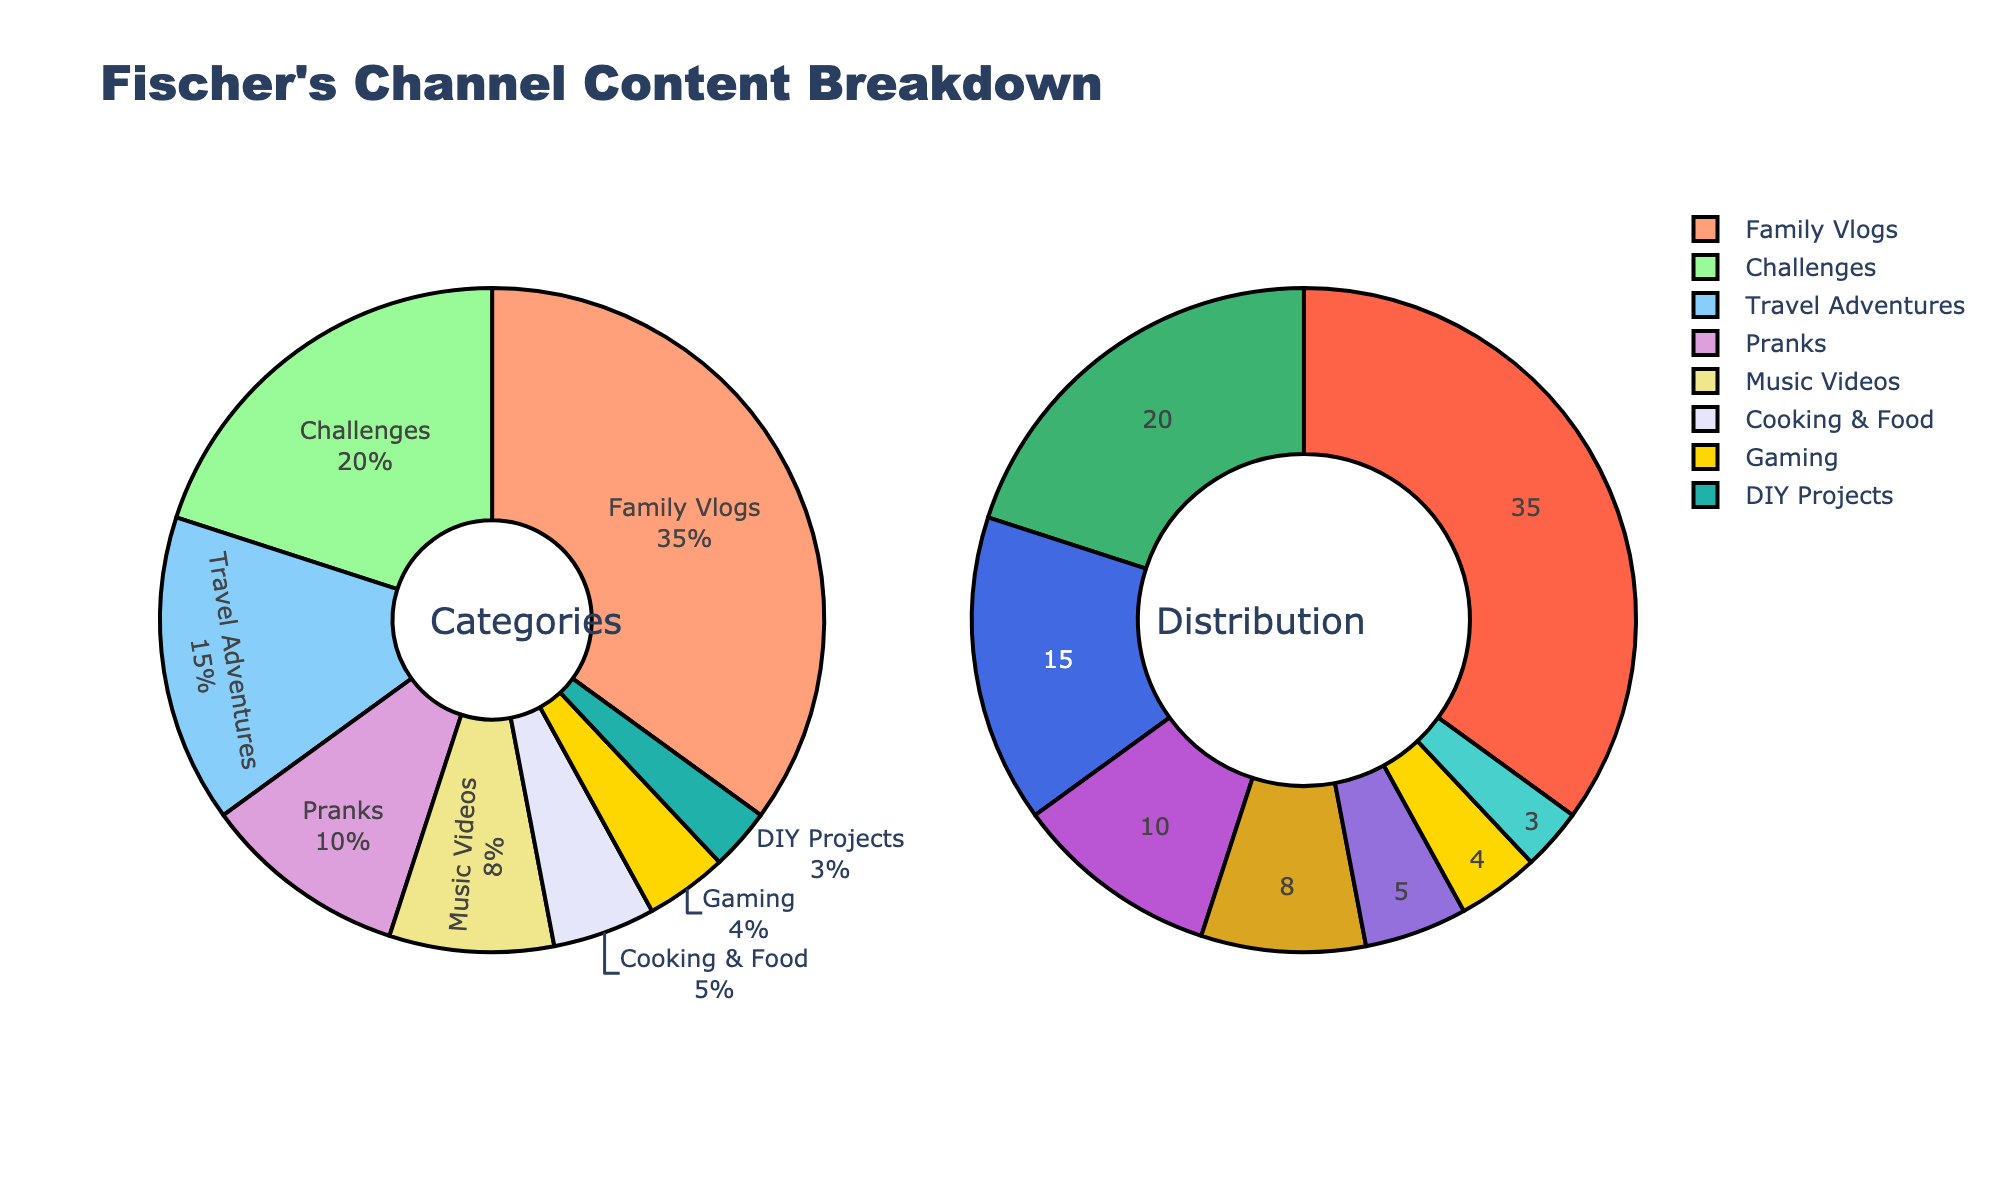How many followers does Jessica Allain have on Instagram? The pie chart labeled 'Followers' indicates the proportion of followers on each platform. From there, we can identify Instagram and the number given in the data: "Instagram - 245,000 followers".
Answer: 245,000 Which platform has the highest share of likes? Looking at the 'Likes' pie chart, we can see the shares of each platform. TikTok has the largest section, indicating it has the highest number of likes.
Answer: TikTok What is the total number of comments across all platforms? To find the total number of comments, we sum the values from each platform. The data shows: Instagram: 2,100, Twitter: 980, TikTok: 4,500, Facebook: 720, YouTube: 1,600. Adding these up: 2100 + 980 + 4500 + 720 + 1600 = 9,900.
Answer: 9,900 Which social media platform has the least number of shares? By looking at the 'Shares' pie chart, we can compare the sections. Facebook has the smallest section, indicating it has the least number of shares, which matches the data (1,500 shares).
Answer: Facebook How does the number of likes on Instagram compare to TikTok? To compare the number of likes, we look at the 'Likes' chart and see Instagram's likes versus TikTok's likes. The data shows Instagram has 18,500 likes and TikTok has 32,000 likes. Hence, TikTok has significantly more likes than Instagram.
Answer: TikTok has more likes If you combine the total engagement (followers, likes, comments, shares) for Instagram and Facebook, what is the sum? Adding the total engagement metrics separately for Instagram (Followers: 245,000, Likes: 18,500, Comments: 2,100, Shares: 3,200) and Facebook (Followers: 62,000, Likes: 3,800, Comments: 720, Shares: 1,500), we get:
Instagram Total: 245,000 + 18,500 + 2,100 + 3,200 = 268,800
Facebook Total: 62,000 + 3,800 + 720 + 1,500 = 68,020.
Sum of both: 268,800 + 68,020 = 336,820.
Answer: 336,820 What's the percentage of total engagement that comes from YouTube? From the 'Platform Distribution' pie chart, we see the total engagement for all platforms. The sum of the figures is Instagram: 268,800, Twitter: 95,280, TikTok: 200,400, Facebook: 68,020, YouTube: 40,600. The total engagement is 268,800 + 95,280 + 156,000 + 68,020 + 40,600 = 628,700. The percentage for YouTube is then (40,600 / 628,700) * 100 which is approximately 6.46%.
Answer: 6.46% Compare the number of comments on TikTok to the total number of shares across all platforms. Which is higher? The number of comments on TikTok is given as 4,500. The total number of shares across all platforms is the sum of comments: 3,200 (Instagram) + 1,700 (Twitter) + 8,900 (TikTok) + 1,500 (Facebook) + 2,800 (YouTube) = 18,100. Comparing the two, the total number of shares (18,100) is higher than the number of comments on TikTok (4,500).
Answer: Total shares are higher 